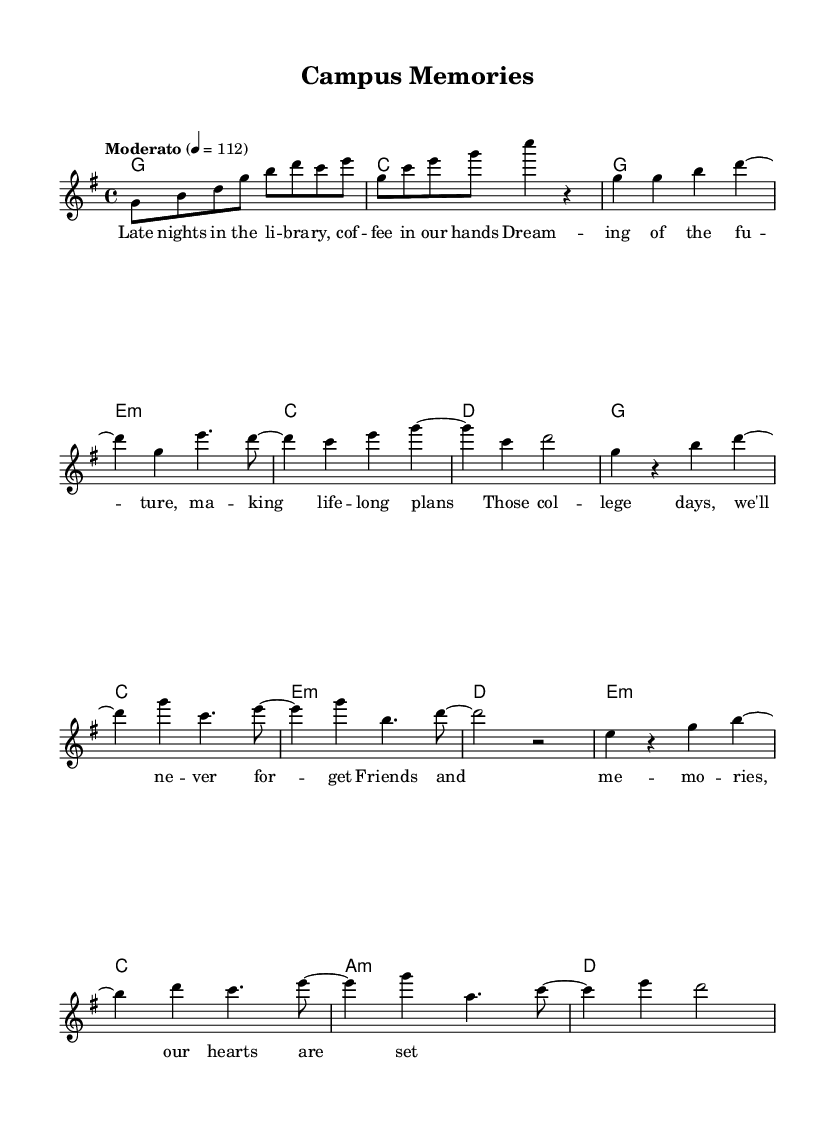What is the key signature of this music? The key signature is G major, which has one sharp (F#). This is evident as the music notation begins with the key signature marking, indicating the presence of F#.
Answer: G major What is the time signature of this music? The time signature is 4/4, which is indicated at the beginning of the score. This means there are four beats in each measure.
Answer: 4/4 What is the tempo marking for this piece? The tempo marking is "Moderato," and it indicates a moderate pace, with a specific speed of 112 beats per minute, noted at the start of the score.
Answer: Moderato How many measures are in the chorus section? The chorus section consists of two measures, indicated clearly by the grouping of notes labeled as the "Chorus" in the sheet music.
Answer: 2 What is the last chord of the bridge section? The last chord of the bridge section is D major, which is indicated at the end of the bridge section in the chord notation.
Answer: D Which lyrical theme is presented in the verse? The lyrical theme in the verse revolves around college experiences such as studying in the library and dreaming about the future, as indicated by the words provided in the lyric section.
Answer: College experiences 